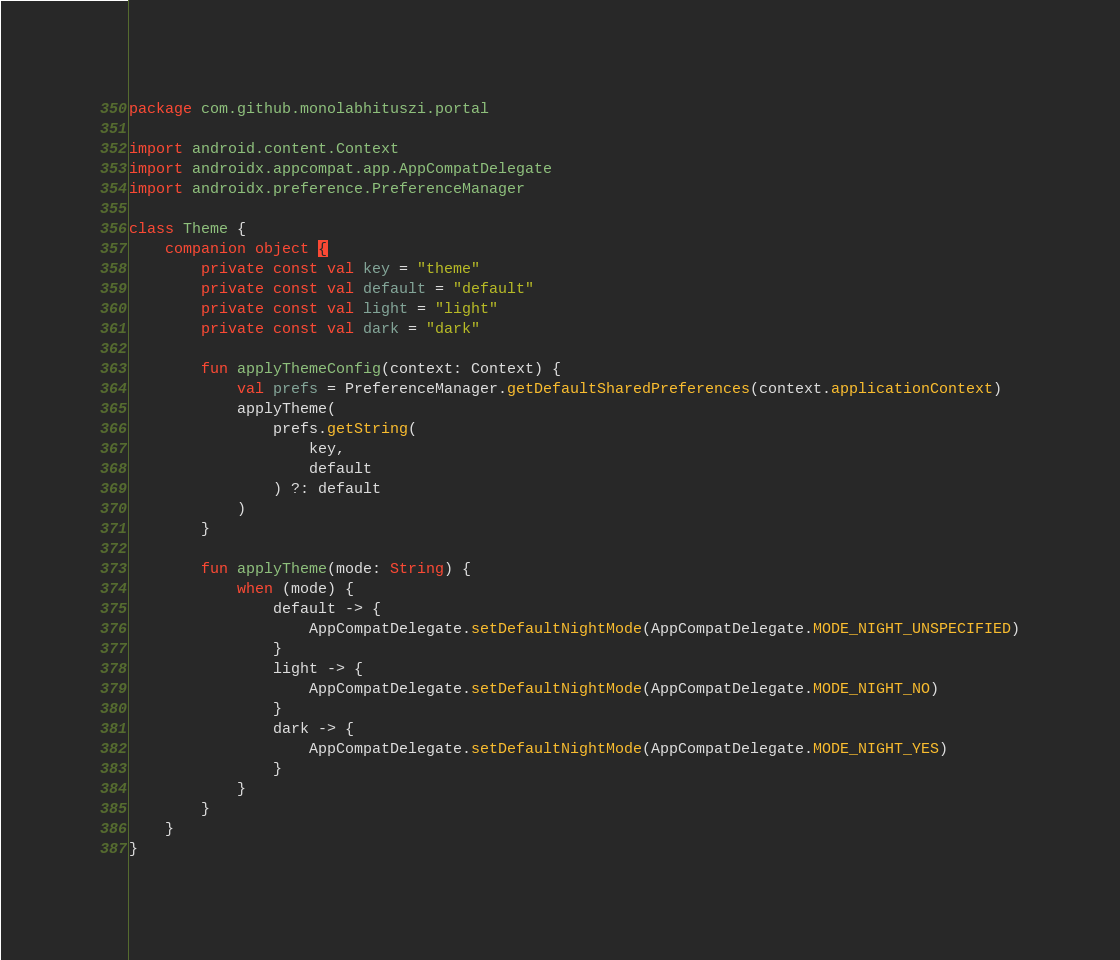<code> <loc_0><loc_0><loc_500><loc_500><_Kotlin_>package com.github.monolabhituszi.portal

import android.content.Context
import androidx.appcompat.app.AppCompatDelegate
import androidx.preference.PreferenceManager

class Theme {
    companion object {
        private const val key = "theme"
        private const val default = "default"
        private const val light = "light"
        private const val dark = "dark"

        fun applyThemeConfig(context: Context) {
            val prefs = PreferenceManager.getDefaultSharedPreferences(context.applicationContext)
            applyTheme(
                prefs.getString(
                    key,
                    default
                ) ?: default
            )
        }

        fun applyTheme(mode: String) {
            when (mode) {
                default -> {
                    AppCompatDelegate.setDefaultNightMode(AppCompatDelegate.MODE_NIGHT_UNSPECIFIED)
                }
                light -> {
                    AppCompatDelegate.setDefaultNightMode(AppCompatDelegate.MODE_NIGHT_NO)
                }
                dark -> {
                    AppCompatDelegate.setDefaultNightMode(AppCompatDelegate.MODE_NIGHT_YES)
                }
            }
        }
    }
}
</code> 